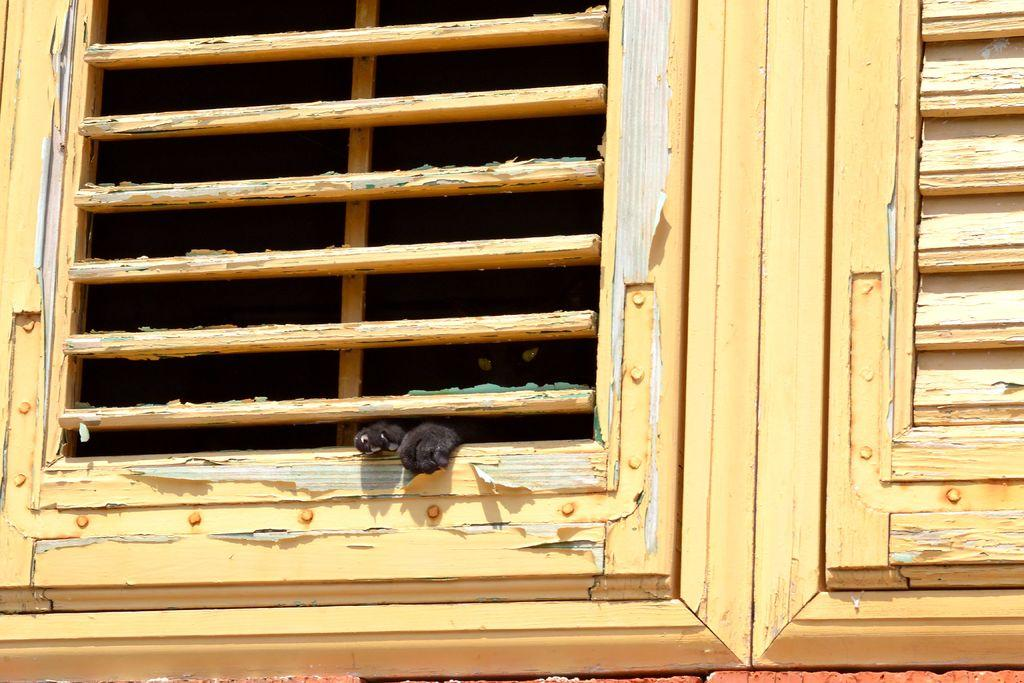What type of windows are present in the image? There are wooden windows in the image. What can be seen at the window in the image? There is an animal standing at the window in the image. What type of furniture is visible in the image? There is no furniture visible in the image; it only features wooden windows and an animal standing at the window. How does the animal feel while standing at the window in the image? We cannot determine the animal's feelings from the image alone, as emotions are not visually observable. 